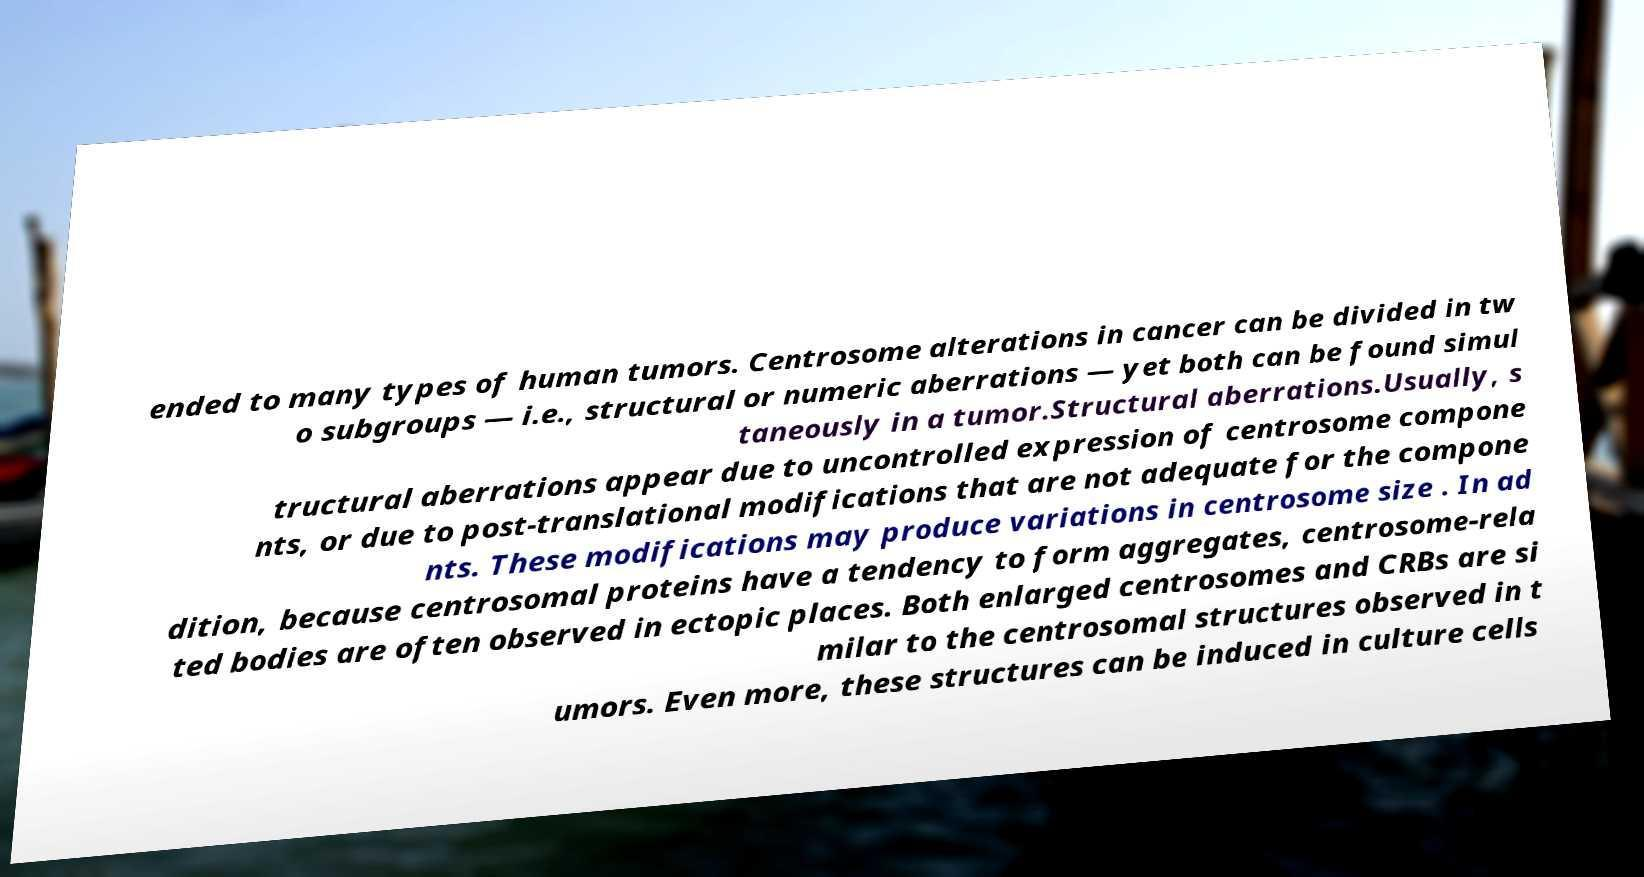Can you read and provide the text displayed in the image?This photo seems to have some interesting text. Can you extract and type it out for me? ended to many types of human tumors. Centrosome alterations in cancer can be divided in tw o subgroups — i.e., structural or numeric aberrations — yet both can be found simul taneously in a tumor.Structural aberrations.Usually, s tructural aberrations appear due to uncontrolled expression of centrosome compone nts, or due to post-translational modifications that are not adequate for the compone nts. These modifications may produce variations in centrosome size . In ad dition, because centrosomal proteins have a tendency to form aggregates, centrosome-rela ted bodies are often observed in ectopic places. Both enlarged centrosomes and CRBs are si milar to the centrosomal structures observed in t umors. Even more, these structures can be induced in culture cells 